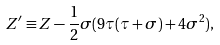<formula> <loc_0><loc_0><loc_500><loc_500>Z ^ { \prime } \equiv Z - \frac { 1 } { 2 } \sigma ( 9 \tau ( \tau + \sigma ) + 4 \sigma ^ { 2 } ) ,</formula> 